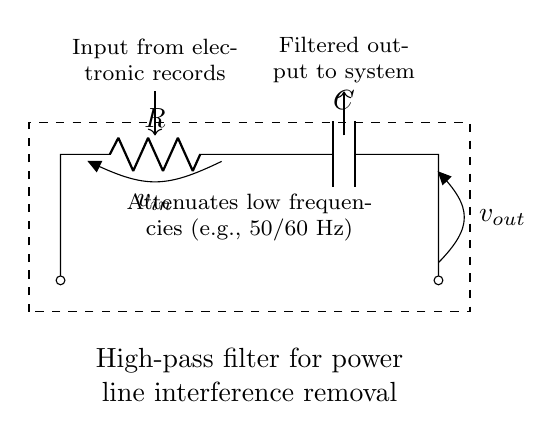What type of filter is represented by this circuit? The circuit represents a high-pass filter, indicated by the arrangement of the resistor and capacitor which allows high frequencies to pass while attenuating low frequencies.
Answer: high-pass filter What component is labeled as R? The label R corresponds to the resistor in the circuit, which is typically used to control current flow and influence the voltage across the capacitor.
Answer: resistor What component is labeled as C? The label C refers to the capacitor in the circuit, which stores electrical energy temporarily and plays a critical role in the filtering action by blocking low-frequency signals.
Answer: capacitor What is attenuated by this filter? The filter attenuates low frequencies, specifically the unwanted noise from power lines typically at 50 or 60 Hz, allowing higher frequencies to be transmitted.
Answer: low frequencies What is the output voltage representative of? The output voltage, labeled as v_out, represents the voltage after the high-pass filtering process, which should be free from low-frequency interference.
Answer: filtered output How does this circuit affect 50/60 Hz signals? The circuit design attenuates the 50 or 60 Hz signals, which are typical power line frequencies, allowing only higher frequency signals to pass through to the output.
Answer: attenuates 